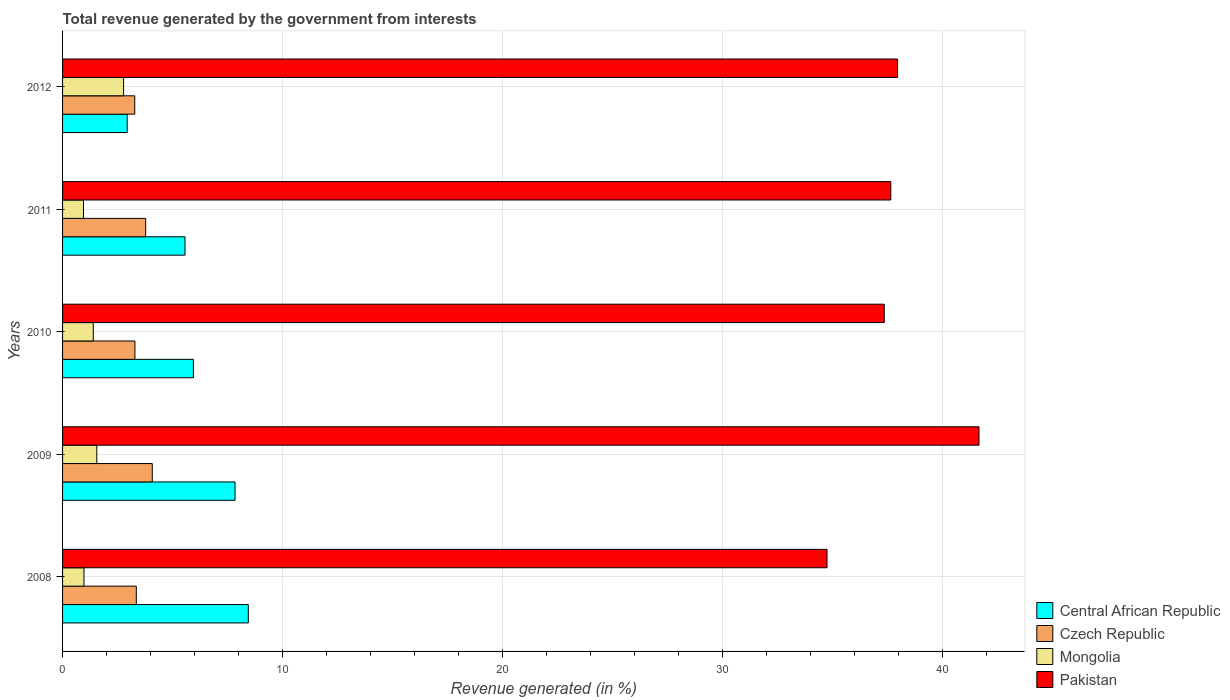How many different coloured bars are there?
Provide a succinct answer. 4. How many groups of bars are there?
Make the answer very short. 5. Are the number of bars on each tick of the Y-axis equal?
Your response must be concise. Yes. How many bars are there on the 4th tick from the bottom?
Make the answer very short. 4. What is the total revenue generated in Mongolia in 2011?
Make the answer very short. 0.95. Across all years, what is the maximum total revenue generated in Central African Republic?
Your answer should be compact. 8.45. Across all years, what is the minimum total revenue generated in Pakistan?
Give a very brief answer. 34.77. In which year was the total revenue generated in Central African Republic minimum?
Make the answer very short. 2012. What is the total total revenue generated in Mongolia in the graph?
Give a very brief answer. 7.66. What is the difference between the total revenue generated in Central African Republic in 2010 and that in 2012?
Ensure brevity in your answer.  3.01. What is the difference between the total revenue generated in Pakistan in 2009 and the total revenue generated in Mongolia in 2012?
Your response must be concise. 38.9. What is the average total revenue generated in Pakistan per year?
Your response must be concise. 37.89. In the year 2011, what is the difference between the total revenue generated in Pakistan and total revenue generated in Czech Republic?
Your answer should be compact. 33.89. What is the ratio of the total revenue generated in Central African Republic in 2010 to that in 2012?
Make the answer very short. 2.02. What is the difference between the highest and the second highest total revenue generated in Mongolia?
Offer a terse response. 1.22. What is the difference between the highest and the lowest total revenue generated in Central African Republic?
Ensure brevity in your answer.  5.51. Is it the case that in every year, the sum of the total revenue generated in Central African Republic and total revenue generated in Czech Republic is greater than the sum of total revenue generated in Pakistan and total revenue generated in Mongolia?
Your response must be concise. No. What does the 3rd bar from the top in 2009 represents?
Provide a short and direct response. Czech Republic. What does the 1st bar from the bottom in 2009 represents?
Give a very brief answer. Central African Republic. How many bars are there?
Keep it short and to the point. 20. Are all the bars in the graph horizontal?
Your answer should be compact. Yes. What is the difference between two consecutive major ticks on the X-axis?
Your answer should be very brief. 10. Does the graph contain any zero values?
Keep it short and to the point. No. Does the graph contain grids?
Make the answer very short. Yes. How many legend labels are there?
Ensure brevity in your answer.  4. How are the legend labels stacked?
Keep it short and to the point. Vertical. What is the title of the graph?
Your response must be concise. Total revenue generated by the government from interests. Does "Guyana" appear as one of the legend labels in the graph?
Make the answer very short. No. What is the label or title of the X-axis?
Provide a succinct answer. Revenue generated (in %). What is the label or title of the Y-axis?
Keep it short and to the point. Years. What is the Revenue generated (in %) in Central African Republic in 2008?
Ensure brevity in your answer.  8.45. What is the Revenue generated (in %) in Czech Republic in 2008?
Give a very brief answer. 3.35. What is the Revenue generated (in %) of Mongolia in 2008?
Provide a succinct answer. 0.97. What is the Revenue generated (in %) in Pakistan in 2008?
Your answer should be very brief. 34.77. What is the Revenue generated (in %) in Central African Republic in 2009?
Provide a short and direct response. 7.85. What is the Revenue generated (in %) of Czech Republic in 2009?
Offer a terse response. 4.08. What is the Revenue generated (in %) in Mongolia in 2009?
Your answer should be compact. 1.56. What is the Revenue generated (in %) of Pakistan in 2009?
Give a very brief answer. 41.68. What is the Revenue generated (in %) in Central African Republic in 2010?
Your response must be concise. 5.95. What is the Revenue generated (in %) in Czech Republic in 2010?
Give a very brief answer. 3.29. What is the Revenue generated (in %) of Mongolia in 2010?
Keep it short and to the point. 1.4. What is the Revenue generated (in %) in Pakistan in 2010?
Your answer should be compact. 37.37. What is the Revenue generated (in %) in Central African Republic in 2011?
Provide a succinct answer. 5.57. What is the Revenue generated (in %) of Czech Republic in 2011?
Your answer should be very brief. 3.78. What is the Revenue generated (in %) in Mongolia in 2011?
Make the answer very short. 0.95. What is the Revenue generated (in %) of Pakistan in 2011?
Offer a terse response. 37.67. What is the Revenue generated (in %) in Central African Republic in 2012?
Your answer should be very brief. 2.94. What is the Revenue generated (in %) of Czech Republic in 2012?
Offer a terse response. 3.28. What is the Revenue generated (in %) in Mongolia in 2012?
Your response must be concise. 2.78. What is the Revenue generated (in %) in Pakistan in 2012?
Provide a short and direct response. 37.98. Across all years, what is the maximum Revenue generated (in %) in Central African Republic?
Offer a very short reply. 8.45. Across all years, what is the maximum Revenue generated (in %) in Czech Republic?
Give a very brief answer. 4.08. Across all years, what is the maximum Revenue generated (in %) in Mongolia?
Give a very brief answer. 2.78. Across all years, what is the maximum Revenue generated (in %) in Pakistan?
Offer a terse response. 41.68. Across all years, what is the minimum Revenue generated (in %) in Central African Republic?
Provide a short and direct response. 2.94. Across all years, what is the minimum Revenue generated (in %) in Czech Republic?
Your answer should be compact. 3.28. Across all years, what is the minimum Revenue generated (in %) in Mongolia?
Provide a succinct answer. 0.95. Across all years, what is the minimum Revenue generated (in %) in Pakistan?
Your answer should be compact. 34.77. What is the total Revenue generated (in %) of Central African Republic in the graph?
Provide a succinct answer. 30.75. What is the total Revenue generated (in %) in Czech Republic in the graph?
Provide a short and direct response. 17.79. What is the total Revenue generated (in %) in Mongolia in the graph?
Offer a terse response. 7.66. What is the total Revenue generated (in %) of Pakistan in the graph?
Your answer should be very brief. 189.47. What is the difference between the Revenue generated (in %) of Central African Republic in 2008 and that in 2009?
Keep it short and to the point. 0.6. What is the difference between the Revenue generated (in %) of Czech Republic in 2008 and that in 2009?
Offer a very short reply. -0.73. What is the difference between the Revenue generated (in %) in Mongolia in 2008 and that in 2009?
Give a very brief answer. -0.58. What is the difference between the Revenue generated (in %) of Pakistan in 2008 and that in 2009?
Provide a short and direct response. -6.91. What is the difference between the Revenue generated (in %) in Central African Republic in 2008 and that in 2010?
Provide a short and direct response. 2.5. What is the difference between the Revenue generated (in %) in Czech Republic in 2008 and that in 2010?
Provide a succinct answer. 0.06. What is the difference between the Revenue generated (in %) of Mongolia in 2008 and that in 2010?
Offer a terse response. -0.42. What is the difference between the Revenue generated (in %) of Pakistan in 2008 and that in 2010?
Keep it short and to the point. -2.6. What is the difference between the Revenue generated (in %) of Central African Republic in 2008 and that in 2011?
Offer a very short reply. 2.88. What is the difference between the Revenue generated (in %) in Czech Republic in 2008 and that in 2011?
Make the answer very short. -0.43. What is the difference between the Revenue generated (in %) of Mongolia in 2008 and that in 2011?
Your answer should be very brief. 0.02. What is the difference between the Revenue generated (in %) in Pakistan in 2008 and that in 2011?
Provide a short and direct response. -2.9. What is the difference between the Revenue generated (in %) in Central African Republic in 2008 and that in 2012?
Keep it short and to the point. 5.51. What is the difference between the Revenue generated (in %) in Czech Republic in 2008 and that in 2012?
Offer a terse response. 0.07. What is the difference between the Revenue generated (in %) of Mongolia in 2008 and that in 2012?
Provide a succinct answer. -1.8. What is the difference between the Revenue generated (in %) in Pakistan in 2008 and that in 2012?
Provide a short and direct response. -3.21. What is the difference between the Revenue generated (in %) in Central African Republic in 2009 and that in 2010?
Make the answer very short. 1.9. What is the difference between the Revenue generated (in %) of Czech Republic in 2009 and that in 2010?
Provide a succinct answer. 0.79. What is the difference between the Revenue generated (in %) of Mongolia in 2009 and that in 2010?
Keep it short and to the point. 0.16. What is the difference between the Revenue generated (in %) in Pakistan in 2009 and that in 2010?
Ensure brevity in your answer.  4.31. What is the difference between the Revenue generated (in %) of Central African Republic in 2009 and that in 2011?
Ensure brevity in your answer.  2.28. What is the difference between the Revenue generated (in %) of Czech Republic in 2009 and that in 2011?
Provide a succinct answer. 0.3. What is the difference between the Revenue generated (in %) in Mongolia in 2009 and that in 2011?
Your answer should be very brief. 0.61. What is the difference between the Revenue generated (in %) in Pakistan in 2009 and that in 2011?
Offer a very short reply. 4.01. What is the difference between the Revenue generated (in %) in Central African Republic in 2009 and that in 2012?
Your answer should be compact. 4.9. What is the difference between the Revenue generated (in %) of Czech Republic in 2009 and that in 2012?
Make the answer very short. 0.8. What is the difference between the Revenue generated (in %) of Mongolia in 2009 and that in 2012?
Your answer should be very brief. -1.22. What is the difference between the Revenue generated (in %) in Pakistan in 2009 and that in 2012?
Make the answer very short. 3.7. What is the difference between the Revenue generated (in %) in Central African Republic in 2010 and that in 2011?
Ensure brevity in your answer.  0.38. What is the difference between the Revenue generated (in %) of Czech Republic in 2010 and that in 2011?
Keep it short and to the point. -0.49. What is the difference between the Revenue generated (in %) in Mongolia in 2010 and that in 2011?
Provide a short and direct response. 0.45. What is the difference between the Revenue generated (in %) of Pakistan in 2010 and that in 2011?
Make the answer very short. -0.3. What is the difference between the Revenue generated (in %) of Central African Republic in 2010 and that in 2012?
Provide a succinct answer. 3.01. What is the difference between the Revenue generated (in %) of Czech Republic in 2010 and that in 2012?
Offer a very short reply. 0.01. What is the difference between the Revenue generated (in %) in Mongolia in 2010 and that in 2012?
Your answer should be compact. -1.38. What is the difference between the Revenue generated (in %) in Pakistan in 2010 and that in 2012?
Provide a short and direct response. -0.61. What is the difference between the Revenue generated (in %) of Central African Republic in 2011 and that in 2012?
Offer a very short reply. 2.63. What is the difference between the Revenue generated (in %) in Czech Republic in 2011 and that in 2012?
Your answer should be very brief. 0.5. What is the difference between the Revenue generated (in %) in Mongolia in 2011 and that in 2012?
Your response must be concise. -1.82. What is the difference between the Revenue generated (in %) of Pakistan in 2011 and that in 2012?
Your answer should be compact. -0.31. What is the difference between the Revenue generated (in %) in Central African Republic in 2008 and the Revenue generated (in %) in Czech Republic in 2009?
Make the answer very short. 4.37. What is the difference between the Revenue generated (in %) in Central African Republic in 2008 and the Revenue generated (in %) in Mongolia in 2009?
Your answer should be very brief. 6.89. What is the difference between the Revenue generated (in %) of Central African Republic in 2008 and the Revenue generated (in %) of Pakistan in 2009?
Your answer should be very brief. -33.23. What is the difference between the Revenue generated (in %) in Czech Republic in 2008 and the Revenue generated (in %) in Mongolia in 2009?
Give a very brief answer. 1.8. What is the difference between the Revenue generated (in %) in Czech Republic in 2008 and the Revenue generated (in %) in Pakistan in 2009?
Provide a short and direct response. -38.33. What is the difference between the Revenue generated (in %) in Mongolia in 2008 and the Revenue generated (in %) in Pakistan in 2009?
Provide a succinct answer. -40.71. What is the difference between the Revenue generated (in %) in Central African Republic in 2008 and the Revenue generated (in %) in Czech Republic in 2010?
Your answer should be compact. 5.16. What is the difference between the Revenue generated (in %) of Central African Republic in 2008 and the Revenue generated (in %) of Mongolia in 2010?
Offer a very short reply. 7.05. What is the difference between the Revenue generated (in %) of Central African Republic in 2008 and the Revenue generated (in %) of Pakistan in 2010?
Your response must be concise. -28.92. What is the difference between the Revenue generated (in %) in Czech Republic in 2008 and the Revenue generated (in %) in Mongolia in 2010?
Offer a terse response. 1.96. What is the difference between the Revenue generated (in %) in Czech Republic in 2008 and the Revenue generated (in %) in Pakistan in 2010?
Your answer should be compact. -34.02. What is the difference between the Revenue generated (in %) in Mongolia in 2008 and the Revenue generated (in %) in Pakistan in 2010?
Provide a succinct answer. -36.4. What is the difference between the Revenue generated (in %) of Central African Republic in 2008 and the Revenue generated (in %) of Czech Republic in 2011?
Make the answer very short. 4.67. What is the difference between the Revenue generated (in %) of Central African Republic in 2008 and the Revenue generated (in %) of Mongolia in 2011?
Provide a short and direct response. 7.5. What is the difference between the Revenue generated (in %) of Central African Republic in 2008 and the Revenue generated (in %) of Pakistan in 2011?
Your answer should be compact. -29.22. What is the difference between the Revenue generated (in %) in Czech Republic in 2008 and the Revenue generated (in %) in Mongolia in 2011?
Your answer should be compact. 2.4. What is the difference between the Revenue generated (in %) of Czech Republic in 2008 and the Revenue generated (in %) of Pakistan in 2011?
Offer a terse response. -34.31. What is the difference between the Revenue generated (in %) in Mongolia in 2008 and the Revenue generated (in %) in Pakistan in 2011?
Make the answer very short. -36.69. What is the difference between the Revenue generated (in %) in Central African Republic in 2008 and the Revenue generated (in %) in Czech Republic in 2012?
Provide a short and direct response. 5.16. What is the difference between the Revenue generated (in %) in Central African Republic in 2008 and the Revenue generated (in %) in Mongolia in 2012?
Your answer should be very brief. 5.67. What is the difference between the Revenue generated (in %) of Central African Republic in 2008 and the Revenue generated (in %) of Pakistan in 2012?
Your answer should be very brief. -29.53. What is the difference between the Revenue generated (in %) of Czech Republic in 2008 and the Revenue generated (in %) of Mongolia in 2012?
Provide a short and direct response. 0.58. What is the difference between the Revenue generated (in %) of Czech Republic in 2008 and the Revenue generated (in %) of Pakistan in 2012?
Keep it short and to the point. -34.62. What is the difference between the Revenue generated (in %) in Mongolia in 2008 and the Revenue generated (in %) in Pakistan in 2012?
Ensure brevity in your answer.  -37. What is the difference between the Revenue generated (in %) of Central African Republic in 2009 and the Revenue generated (in %) of Czech Republic in 2010?
Keep it short and to the point. 4.55. What is the difference between the Revenue generated (in %) of Central African Republic in 2009 and the Revenue generated (in %) of Mongolia in 2010?
Your answer should be very brief. 6.45. What is the difference between the Revenue generated (in %) of Central African Republic in 2009 and the Revenue generated (in %) of Pakistan in 2010?
Provide a succinct answer. -29.53. What is the difference between the Revenue generated (in %) in Czech Republic in 2009 and the Revenue generated (in %) in Mongolia in 2010?
Keep it short and to the point. 2.68. What is the difference between the Revenue generated (in %) of Czech Republic in 2009 and the Revenue generated (in %) of Pakistan in 2010?
Your response must be concise. -33.29. What is the difference between the Revenue generated (in %) of Mongolia in 2009 and the Revenue generated (in %) of Pakistan in 2010?
Provide a succinct answer. -35.81. What is the difference between the Revenue generated (in %) in Central African Republic in 2009 and the Revenue generated (in %) in Czech Republic in 2011?
Your response must be concise. 4.07. What is the difference between the Revenue generated (in %) in Central African Republic in 2009 and the Revenue generated (in %) in Mongolia in 2011?
Give a very brief answer. 6.89. What is the difference between the Revenue generated (in %) of Central African Republic in 2009 and the Revenue generated (in %) of Pakistan in 2011?
Your answer should be compact. -29.82. What is the difference between the Revenue generated (in %) in Czech Republic in 2009 and the Revenue generated (in %) in Mongolia in 2011?
Your answer should be compact. 3.13. What is the difference between the Revenue generated (in %) of Czech Republic in 2009 and the Revenue generated (in %) of Pakistan in 2011?
Provide a succinct answer. -33.59. What is the difference between the Revenue generated (in %) in Mongolia in 2009 and the Revenue generated (in %) in Pakistan in 2011?
Your answer should be very brief. -36.11. What is the difference between the Revenue generated (in %) in Central African Republic in 2009 and the Revenue generated (in %) in Czech Republic in 2012?
Give a very brief answer. 4.56. What is the difference between the Revenue generated (in %) in Central African Republic in 2009 and the Revenue generated (in %) in Mongolia in 2012?
Keep it short and to the point. 5.07. What is the difference between the Revenue generated (in %) in Central African Republic in 2009 and the Revenue generated (in %) in Pakistan in 2012?
Provide a short and direct response. -30.13. What is the difference between the Revenue generated (in %) of Czech Republic in 2009 and the Revenue generated (in %) of Mongolia in 2012?
Give a very brief answer. 1.31. What is the difference between the Revenue generated (in %) of Czech Republic in 2009 and the Revenue generated (in %) of Pakistan in 2012?
Keep it short and to the point. -33.9. What is the difference between the Revenue generated (in %) in Mongolia in 2009 and the Revenue generated (in %) in Pakistan in 2012?
Offer a very short reply. -36.42. What is the difference between the Revenue generated (in %) of Central African Republic in 2010 and the Revenue generated (in %) of Czech Republic in 2011?
Keep it short and to the point. 2.17. What is the difference between the Revenue generated (in %) in Central African Republic in 2010 and the Revenue generated (in %) in Mongolia in 2011?
Provide a succinct answer. 5. What is the difference between the Revenue generated (in %) in Central African Republic in 2010 and the Revenue generated (in %) in Pakistan in 2011?
Offer a terse response. -31.72. What is the difference between the Revenue generated (in %) of Czech Republic in 2010 and the Revenue generated (in %) of Mongolia in 2011?
Provide a short and direct response. 2.34. What is the difference between the Revenue generated (in %) of Czech Republic in 2010 and the Revenue generated (in %) of Pakistan in 2011?
Your answer should be very brief. -34.38. What is the difference between the Revenue generated (in %) of Mongolia in 2010 and the Revenue generated (in %) of Pakistan in 2011?
Ensure brevity in your answer.  -36.27. What is the difference between the Revenue generated (in %) of Central African Republic in 2010 and the Revenue generated (in %) of Czech Republic in 2012?
Offer a terse response. 2.67. What is the difference between the Revenue generated (in %) of Central African Republic in 2010 and the Revenue generated (in %) of Mongolia in 2012?
Ensure brevity in your answer.  3.17. What is the difference between the Revenue generated (in %) of Central African Republic in 2010 and the Revenue generated (in %) of Pakistan in 2012?
Offer a terse response. -32.03. What is the difference between the Revenue generated (in %) in Czech Republic in 2010 and the Revenue generated (in %) in Mongolia in 2012?
Provide a succinct answer. 0.52. What is the difference between the Revenue generated (in %) of Czech Republic in 2010 and the Revenue generated (in %) of Pakistan in 2012?
Your response must be concise. -34.69. What is the difference between the Revenue generated (in %) of Mongolia in 2010 and the Revenue generated (in %) of Pakistan in 2012?
Your answer should be compact. -36.58. What is the difference between the Revenue generated (in %) of Central African Republic in 2011 and the Revenue generated (in %) of Czech Republic in 2012?
Provide a succinct answer. 2.29. What is the difference between the Revenue generated (in %) in Central African Republic in 2011 and the Revenue generated (in %) in Mongolia in 2012?
Provide a short and direct response. 2.79. What is the difference between the Revenue generated (in %) of Central African Republic in 2011 and the Revenue generated (in %) of Pakistan in 2012?
Keep it short and to the point. -32.41. What is the difference between the Revenue generated (in %) of Czech Republic in 2011 and the Revenue generated (in %) of Mongolia in 2012?
Your answer should be very brief. 1. What is the difference between the Revenue generated (in %) in Czech Republic in 2011 and the Revenue generated (in %) in Pakistan in 2012?
Your response must be concise. -34.2. What is the difference between the Revenue generated (in %) of Mongolia in 2011 and the Revenue generated (in %) of Pakistan in 2012?
Ensure brevity in your answer.  -37.03. What is the average Revenue generated (in %) in Central African Republic per year?
Your answer should be very brief. 6.15. What is the average Revenue generated (in %) in Czech Republic per year?
Give a very brief answer. 3.56. What is the average Revenue generated (in %) in Mongolia per year?
Offer a terse response. 1.53. What is the average Revenue generated (in %) of Pakistan per year?
Make the answer very short. 37.89. In the year 2008, what is the difference between the Revenue generated (in %) of Central African Republic and Revenue generated (in %) of Czech Republic?
Ensure brevity in your answer.  5.09. In the year 2008, what is the difference between the Revenue generated (in %) in Central African Republic and Revenue generated (in %) in Mongolia?
Offer a very short reply. 7.47. In the year 2008, what is the difference between the Revenue generated (in %) in Central African Republic and Revenue generated (in %) in Pakistan?
Provide a short and direct response. -26.32. In the year 2008, what is the difference between the Revenue generated (in %) in Czech Republic and Revenue generated (in %) in Mongolia?
Ensure brevity in your answer.  2.38. In the year 2008, what is the difference between the Revenue generated (in %) in Czech Republic and Revenue generated (in %) in Pakistan?
Your answer should be very brief. -31.41. In the year 2008, what is the difference between the Revenue generated (in %) of Mongolia and Revenue generated (in %) of Pakistan?
Provide a short and direct response. -33.79. In the year 2009, what is the difference between the Revenue generated (in %) in Central African Republic and Revenue generated (in %) in Czech Republic?
Ensure brevity in your answer.  3.76. In the year 2009, what is the difference between the Revenue generated (in %) in Central African Republic and Revenue generated (in %) in Mongolia?
Offer a very short reply. 6.29. In the year 2009, what is the difference between the Revenue generated (in %) of Central African Republic and Revenue generated (in %) of Pakistan?
Provide a short and direct response. -33.84. In the year 2009, what is the difference between the Revenue generated (in %) of Czech Republic and Revenue generated (in %) of Mongolia?
Keep it short and to the point. 2.52. In the year 2009, what is the difference between the Revenue generated (in %) in Czech Republic and Revenue generated (in %) in Pakistan?
Offer a very short reply. -37.6. In the year 2009, what is the difference between the Revenue generated (in %) of Mongolia and Revenue generated (in %) of Pakistan?
Offer a terse response. -40.12. In the year 2010, what is the difference between the Revenue generated (in %) in Central African Republic and Revenue generated (in %) in Czech Republic?
Your answer should be compact. 2.66. In the year 2010, what is the difference between the Revenue generated (in %) in Central African Republic and Revenue generated (in %) in Mongolia?
Offer a very short reply. 4.55. In the year 2010, what is the difference between the Revenue generated (in %) of Central African Republic and Revenue generated (in %) of Pakistan?
Provide a succinct answer. -31.42. In the year 2010, what is the difference between the Revenue generated (in %) of Czech Republic and Revenue generated (in %) of Mongolia?
Your response must be concise. 1.89. In the year 2010, what is the difference between the Revenue generated (in %) of Czech Republic and Revenue generated (in %) of Pakistan?
Provide a short and direct response. -34.08. In the year 2010, what is the difference between the Revenue generated (in %) in Mongolia and Revenue generated (in %) in Pakistan?
Your answer should be compact. -35.97. In the year 2011, what is the difference between the Revenue generated (in %) in Central African Republic and Revenue generated (in %) in Czech Republic?
Your response must be concise. 1.79. In the year 2011, what is the difference between the Revenue generated (in %) of Central African Republic and Revenue generated (in %) of Mongolia?
Offer a very short reply. 4.62. In the year 2011, what is the difference between the Revenue generated (in %) of Central African Republic and Revenue generated (in %) of Pakistan?
Offer a terse response. -32.1. In the year 2011, what is the difference between the Revenue generated (in %) of Czech Republic and Revenue generated (in %) of Mongolia?
Make the answer very short. 2.83. In the year 2011, what is the difference between the Revenue generated (in %) in Czech Republic and Revenue generated (in %) in Pakistan?
Keep it short and to the point. -33.89. In the year 2011, what is the difference between the Revenue generated (in %) in Mongolia and Revenue generated (in %) in Pakistan?
Provide a short and direct response. -36.72. In the year 2012, what is the difference between the Revenue generated (in %) of Central African Republic and Revenue generated (in %) of Czech Republic?
Your answer should be very brief. -0.34. In the year 2012, what is the difference between the Revenue generated (in %) of Central African Republic and Revenue generated (in %) of Mongolia?
Your response must be concise. 0.17. In the year 2012, what is the difference between the Revenue generated (in %) in Central African Republic and Revenue generated (in %) in Pakistan?
Offer a terse response. -35.04. In the year 2012, what is the difference between the Revenue generated (in %) in Czech Republic and Revenue generated (in %) in Mongolia?
Ensure brevity in your answer.  0.51. In the year 2012, what is the difference between the Revenue generated (in %) in Czech Republic and Revenue generated (in %) in Pakistan?
Your response must be concise. -34.69. In the year 2012, what is the difference between the Revenue generated (in %) in Mongolia and Revenue generated (in %) in Pakistan?
Provide a succinct answer. -35.2. What is the ratio of the Revenue generated (in %) in Central African Republic in 2008 to that in 2009?
Your answer should be compact. 1.08. What is the ratio of the Revenue generated (in %) in Czech Republic in 2008 to that in 2009?
Provide a succinct answer. 0.82. What is the ratio of the Revenue generated (in %) in Mongolia in 2008 to that in 2009?
Make the answer very short. 0.63. What is the ratio of the Revenue generated (in %) in Pakistan in 2008 to that in 2009?
Provide a succinct answer. 0.83. What is the ratio of the Revenue generated (in %) in Central African Republic in 2008 to that in 2010?
Keep it short and to the point. 1.42. What is the ratio of the Revenue generated (in %) in Czech Republic in 2008 to that in 2010?
Give a very brief answer. 1.02. What is the ratio of the Revenue generated (in %) in Mongolia in 2008 to that in 2010?
Make the answer very short. 0.7. What is the ratio of the Revenue generated (in %) in Pakistan in 2008 to that in 2010?
Provide a succinct answer. 0.93. What is the ratio of the Revenue generated (in %) in Central African Republic in 2008 to that in 2011?
Keep it short and to the point. 1.52. What is the ratio of the Revenue generated (in %) of Czech Republic in 2008 to that in 2011?
Your answer should be compact. 0.89. What is the ratio of the Revenue generated (in %) of Mongolia in 2008 to that in 2011?
Make the answer very short. 1.02. What is the ratio of the Revenue generated (in %) in Pakistan in 2008 to that in 2011?
Ensure brevity in your answer.  0.92. What is the ratio of the Revenue generated (in %) of Central African Republic in 2008 to that in 2012?
Your answer should be compact. 2.87. What is the ratio of the Revenue generated (in %) of Czech Republic in 2008 to that in 2012?
Make the answer very short. 1.02. What is the ratio of the Revenue generated (in %) in Mongolia in 2008 to that in 2012?
Make the answer very short. 0.35. What is the ratio of the Revenue generated (in %) of Pakistan in 2008 to that in 2012?
Your response must be concise. 0.92. What is the ratio of the Revenue generated (in %) of Central African Republic in 2009 to that in 2010?
Give a very brief answer. 1.32. What is the ratio of the Revenue generated (in %) of Czech Republic in 2009 to that in 2010?
Your response must be concise. 1.24. What is the ratio of the Revenue generated (in %) in Mongolia in 2009 to that in 2010?
Your response must be concise. 1.11. What is the ratio of the Revenue generated (in %) of Pakistan in 2009 to that in 2010?
Provide a succinct answer. 1.12. What is the ratio of the Revenue generated (in %) in Central African Republic in 2009 to that in 2011?
Your answer should be very brief. 1.41. What is the ratio of the Revenue generated (in %) of Czech Republic in 2009 to that in 2011?
Keep it short and to the point. 1.08. What is the ratio of the Revenue generated (in %) in Mongolia in 2009 to that in 2011?
Provide a short and direct response. 1.64. What is the ratio of the Revenue generated (in %) in Pakistan in 2009 to that in 2011?
Keep it short and to the point. 1.11. What is the ratio of the Revenue generated (in %) in Central African Republic in 2009 to that in 2012?
Your response must be concise. 2.67. What is the ratio of the Revenue generated (in %) of Czech Republic in 2009 to that in 2012?
Offer a terse response. 1.24. What is the ratio of the Revenue generated (in %) of Mongolia in 2009 to that in 2012?
Make the answer very short. 0.56. What is the ratio of the Revenue generated (in %) of Pakistan in 2009 to that in 2012?
Keep it short and to the point. 1.1. What is the ratio of the Revenue generated (in %) of Central African Republic in 2010 to that in 2011?
Offer a terse response. 1.07. What is the ratio of the Revenue generated (in %) of Czech Republic in 2010 to that in 2011?
Your answer should be very brief. 0.87. What is the ratio of the Revenue generated (in %) in Mongolia in 2010 to that in 2011?
Offer a very short reply. 1.47. What is the ratio of the Revenue generated (in %) in Central African Republic in 2010 to that in 2012?
Make the answer very short. 2.02. What is the ratio of the Revenue generated (in %) of Mongolia in 2010 to that in 2012?
Provide a short and direct response. 0.5. What is the ratio of the Revenue generated (in %) of Pakistan in 2010 to that in 2012?
Keep it short and to the point. 0.98. What is the ratio of the Revenue generated (in %) of Central African Republic in 2011 to that in 2012?
Your answer should be very brief. 1.89. What is the ratio of the Revenue generated (in %) of Czech Republic in 2011 to that in 2012?
Offer a very short reply. 1.15. What is the ratio of the Revenue generated (in %) in Mongolia in 2011 to that in 2012?
Your answer should be compact. 0.34. What is the difference between the highest and the second highest Revenue generated (in %) in Central African Republic?
Your response must be concise. 0.6. What is the difference between the highest and the second highest Revenue generated (in %) of Czech Republic?
Offer a very short reply. 0.3. What is the difference between the highest and the second highest Revenue generated (in %) of Mongolia?
Give a very brief answer. 1.22. What is the difference between the highest and the second highest Revenue generated (in %) of Pakistan?
Make the answer very short. 3.7. What is the difference between the highest and the lowest Revenue generated (in %) of Central African Republic?
Your response must be concise. 5.51. What is the difference between the highest and the lowest Revenue generated (in %) of Czech Republic?
Offer a very short reply. 0.8. What is the difference between the highest and the lowest Revenue generated (in %) of Mongolia?
Offer a very short reply. 1.82. What is the difference between the highest and the lowest Revenue generated (in %) in Pakistan?
Your answer should be very brief. 6.91. 